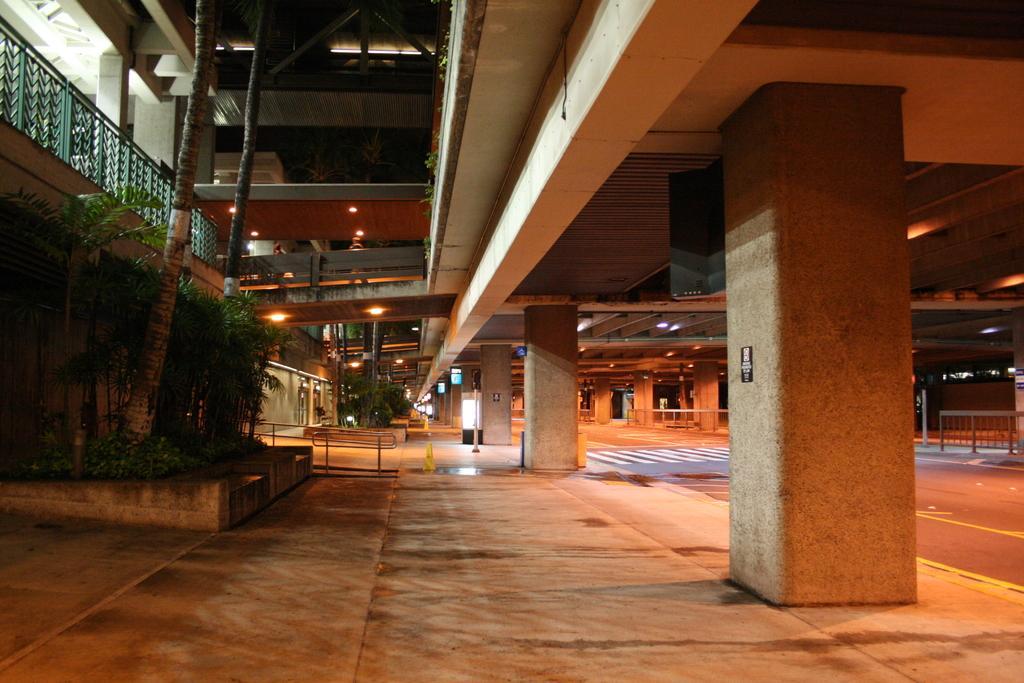How would you summarize this image in a sentence or two? This is an outside view. On the right side I can see a bridge, under this there is a road. On the left side I can see a building and some trees. This is an image clicked in the dark. 